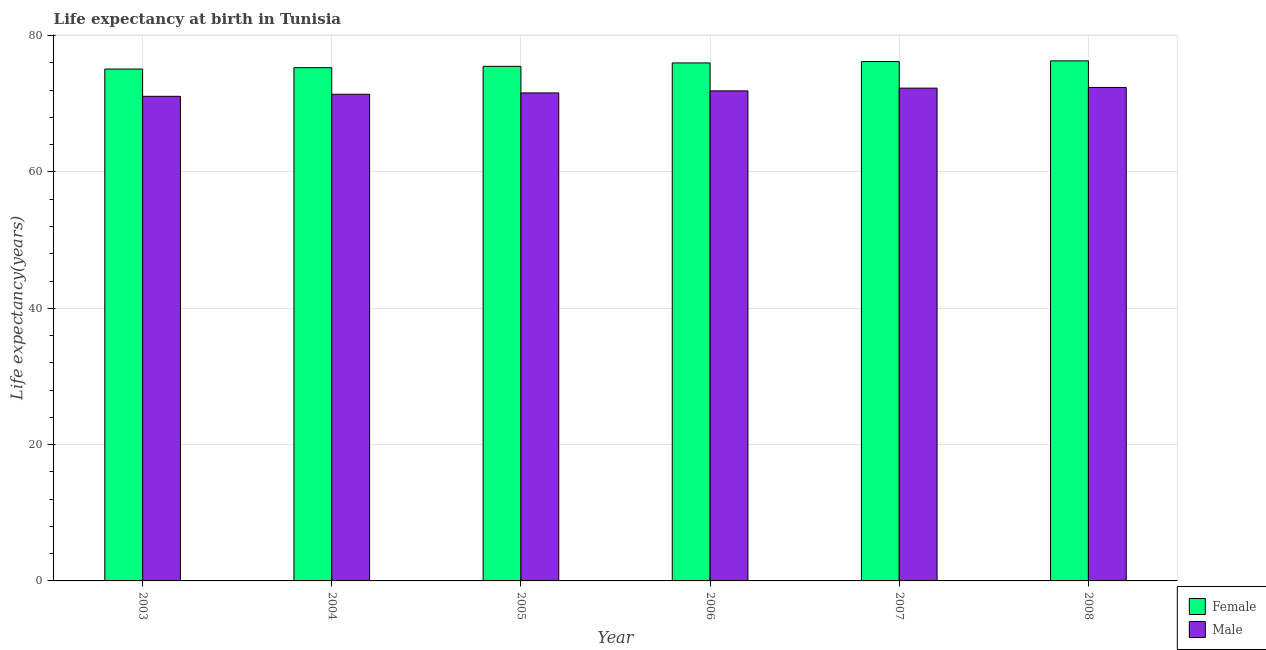How many groups of bars are there?
Offer a terse response. 6. What is the label of the 3rd group of bars from the left?
Provide a succinct answer. 2005. In how many cases, is the number of bars for a given year not equal to the number of legend labels?
Offer a very short reply. 0. What is the life expectancy(male) in 2005?
Offer a terse response. 71.6. Across all years, what is the maximum life expectancy(female)?
Provide a succinct answer. 76.3. Across all years, what is the minimum life expectancy(female)?
Keep it short and to the point. 75.1. In which year was the life expectancy(female) maximum?
Offer a terse response. 2008. In which year was the life expectancy(female) minimum?
Your answer should be very brief. 2003. What is the total life expectancy(female) in the graph?
Ensure brevity in your answer.  454.4. What is the difference between the life expectancy(female) in 2007 and that in 2008?
Provide a short and direct response. -0.1. What is the difference between the life expectancy(female) in 2003 and the life expectancy(male) in 2005?
Provide a short and direct response. -0.4. What is the average life expectancy(male) per year?
Keep it short and to the point. 71.78. In the year 2006, what is the difference between the life expectancy(male) and life expectancy(female)?
Ensure brevity in your answer.  0. What is the ratio of the life expectancy(female) in 2007 to that in 2008?
Your answer should be very brief. 1. Is the difference between the life expectancy(male) in 2005 and 2007 greater than the difference between the life expectancy(female) in 2005 and 2007?
Keep it short and to the point. No. What is the difference between the highest and the second highest life expectancy(male)?
Provide a short and direct response. 0.1. What is the difference between the highest and the lowest life expectancy(male)?
Provide a short and direct response. 1.3. What does the 1st bar from the left in 2003 represents?
Keep it short and to the point. Female. What does the 1st bar from the right in 2006 represents?
Your answer should be very brief. Male. Are the values on the major ticks of Y-axis written in scientific E-notation?
Your answer should be compact. No. Does the graph contain any zero values?
Ensure brevity in your answer.  No. Where does the legend appear in the graph?
Provide a short and direct response. Bottom right. How are the legend labels stacked?
Give a very brief answer. Vertical. What is the title of the graph?
Provide a short and direct response. Life expectancy at birth in Tunisia. Does "Time to import" appear as one of the legend labels in the graph?
Ensure brevity in your answer.  No. What is the label or title of the Y-axis?
Provide a short and direct response. Life expectancy(years). What is the Life expectancy(years) of Female in 2003?
Provide a succinct answer. 75.1. What is the Life expectancy(years) in Male in 2003?
Provide a short and direct response. 71.1. What is the Life expectancy(years) of Female in 2004?
Give a very brief answer. 75.3. What is the Life expectancy(years) of Male in 2004?
Offer a terse response. 71.4. What is the Life expectancy(years) of Female in 2005?
Offer a terse response. 75.5. What is the Life expectancy(years) in Male in 2005?
Offer a terse response. 71.6. What is the Life expectancy(years) in Female in 2006?
Keep it short and to the point. 76. What is the Life expectancy(years) in Male in 2006?
Provide a succinct answer. 71.9. What is the Life expectancy(years) in Female in 2007?
Provide a succinct answer. 76.2. What is the Life expectancy(years) in Male in 2007?
Offer a terse response. 72.3. What is the Life expectancy(years) in Female in 2008?
Offer a terse response. 76.3. What is the Life expectancy(years) in Male in 2008?
Provide a short and direct response. 72.4. Across all years, what is the maximum Life expectancy(years) of Female?
Make the answer very short. 76.3. Across all years, what is the maximum Life expectancy(years) of Male?
Offer a very short reply. 72.4. Across all years, what is the minimum Life expectancy(years) of Female?
Your response must be concise. 75.1. Across all years, what is the minimum Life expectancy(years) of Male?
Your response must be concise. 71.1. What is the total Life expectancy(years) in Female in the graph?
Keep it short and to the point. 454.4. What is the total Life expectancy(years) in Male in the graph?
Keep it short and to the point. 430.7. What is the difference between the Life expectancy(years) of Male in 2003 and that in 2004?
Ensure brevity in your answer.  -0.3. What is the difference between the Life expectancy(years) of Male in 2003 and that in 2005?
Ensure brevity in your answer.  -0.5. What is the difference between the Life expectancy(years) of Female in 2003 and that in 2006?
Ensure brevity in your answer.  -0.9. What is the difference between the Life expectancy(years) of Male in 2003 and that in 2006?
Make the answer very short. -0.8. What is the difference between the Life expectancy(years) of Female in 2003 and that in 2007?
Your response must be concise. -1.1. What is the difference between the Life expectancy(years) of Male in 2003 and that in 2007?
Provide a succinct answer. -1.2. What is the difference between the Life expectancy(years) of Female in 2004 and that in 2006?
Ensure brevity in your answer.  -0.7. What is the difference between the Life expectancy(years) in Male in 2004 and that in 2006?
Provide a short and direct response. -0.5. What is the difference between the Life expectancy(years) of Female in 2004 and that in 2007?
Your response must be concise. -0.9. What is the difference between the Life expectancy(years) of Female in 2004 and that in 2008?
Provide a succinct answer. -1. What is the difference between the Life expectancy(years) of Male in 2004 and that in 2008?
Provide a short and direct response. -1. What is the difference between the Life expectancy(years) of Female in 2005 and that in 2006?
Make the answer very short. -0.5. What is the difference between the Life expectancy(years) of Male in 2005 and that in 2007?
Make the answer very short. -0.7. What is the difference between the Life expectancy(years) in Female in 2005 and that in 2008?
Your response must be concise. -0.8. What is the difference between the Life expectancy(years) in Male in 2006 and that in 2007?
Ensure brevity in your answer.  -0.4. What is the difference between the Life expectancy(years) in Female in 2006 and that in 2008?
Keep it short and to the point. -0.3. What is the difference between the Life expectancy(years) in Male in 2007 and that in 2008?
Your answer should be very brief. -0.1. What is the difference between the Life expectancy(years) in Female in 2003 and the Life expectancy(years) in Male in 2004?
Provide a succinct answer. 3.7. What is the difference between the Life expectancy(years) in Female in 2003 and the Life expectancy(years) in Male in 2005?
Your response must be concise. 3.5. What is the difference between the Life expectancy(years) of Female in 2003 and the Life expectancy(years) of Male in 2006?
Your answer should be compact. 3.2. What is the difference between the Life expectancy(years) in Female in 2003 and the Life expectancy(years) in Male in 2008?
Give a very brief answer. 2.7. What is the difference between the Life expectancy(years) of Female in 2004 and the Life expectancy(years) of Male in 2007?
Offer a terse response. 3. What is the difference between the Life expectancy(years) in Female in 2005 and the Life expectancy(years) in Male in 2006?
Offer a terse response. 3.6. What is the difference between the Life expectancy(years) of Female in 2007 and the Life expectancy(years) of Male in 2008?
Offer a terse response. 3.8. What is the average Life expectancy(years) in Female per year?
Make the answer very short. 75.73. What is the average Life expectancy(years) in Male per year?
Your answer should be compact. 71.78. In the year 2003, what is the difference between the Life expectancy(years) of Female and Life expectancy(years) of Male?
Provide a succinct answer. 4. In the year 2004, what is the difference between the Life expectancy(years) in Female and Life expectancy(years) in Male?
Offer a terse response. 3.9. In the year 2007, what is the difference between the Life expectancy(years) in Female and Life expectancy(years) in Male?
Give a very brief answer. 3.9. What is the ratio of the Life expectancy(years) of Male in 2003 to that in 2004?
Provide a succinct answer. 1. What is the ratio of the Life expectancy(years) of Male in 2003 to that in 2006?
Offer a very short reply. 0.99. What is the ratio of the Life expectancy(years) in Female in 2003 to that in 2007?
Ensure brevity in your answer.  0.99. What is the ratio of the Life expectancy(years) of Male in 2003 to that in 2007?
Give a very brief answer. 0.98. What is the ratio of the Life expectancy(years) in Female in 2003 to that in 2008?
Make the answer very short. 0.98. What is the ratio of the Life expectancy(years) in Male in 2003 to that in 2008?
Your answer should be compact. 0.98. What is the ratio of the Life expectancy(years) in Male in 2004 to that in 2005?
Give a very brief answer. 1. What is the ratio of the Life expectancy(years) in Female in 2004 to that in 2006?
Your response must be concise. 0.99. What is the ratio of the Life expectancy(years) in Male in 2004 to that in 2007?
Make the answer very short. 0.99. What is the ratio of the Life expectancy(years) of Female in 2004 to that in 2008?
Your answer should be very brief. 0.99. What is the ratio of the Life expectancy(years) in Male in 2004 to that in 2008?
Make the answer very short. 0.99. What is the ratio of the Life expectancy(years) of Female in 2005 to that in 2006?
Keep it short and to the point. 0.99. What is the ratio of the Life expectancy(years) of Male in 2005 to that in 2007?
Provide a succinct answer. 0.99. What is the ratio of the Life expectancy(years) of Female in 2005 to that in 2008?
Your answer should be very brief. 0.99. What is the ratio of the Life expectancy(years) of Male in 2005 to that in 2008?
Your response must be concise. 0.99. What is the ratio of the Life expectancy(years) of Female in 2006 to that in 2007?
Your answer should be compact. 1. What is the ratio of the Life expectancy(years) in Male in 2006 to that in 2007?
Keep it short and to the point. 0.99. What is the ratio of the Life expectancy(years) in Male in 2007 to that in 2008?
Your answer should be compact. 1. What is the difference between the highest and the second highest Life expectancy(years) in Female?
Provide a succinct answer. 0.1. What is the difference between the highest and the second highest Life expectancy(years) of Male?
Provide a succinct answer. 0.1. What is the difference between the highest and the lowest Life expectancy(years) in Female?
Ensure brevity in your answer.  1.2. What is the difference between the highest and the lowest Life expectancy(years) of Male?
Provide a short and direct response. 1.3. 